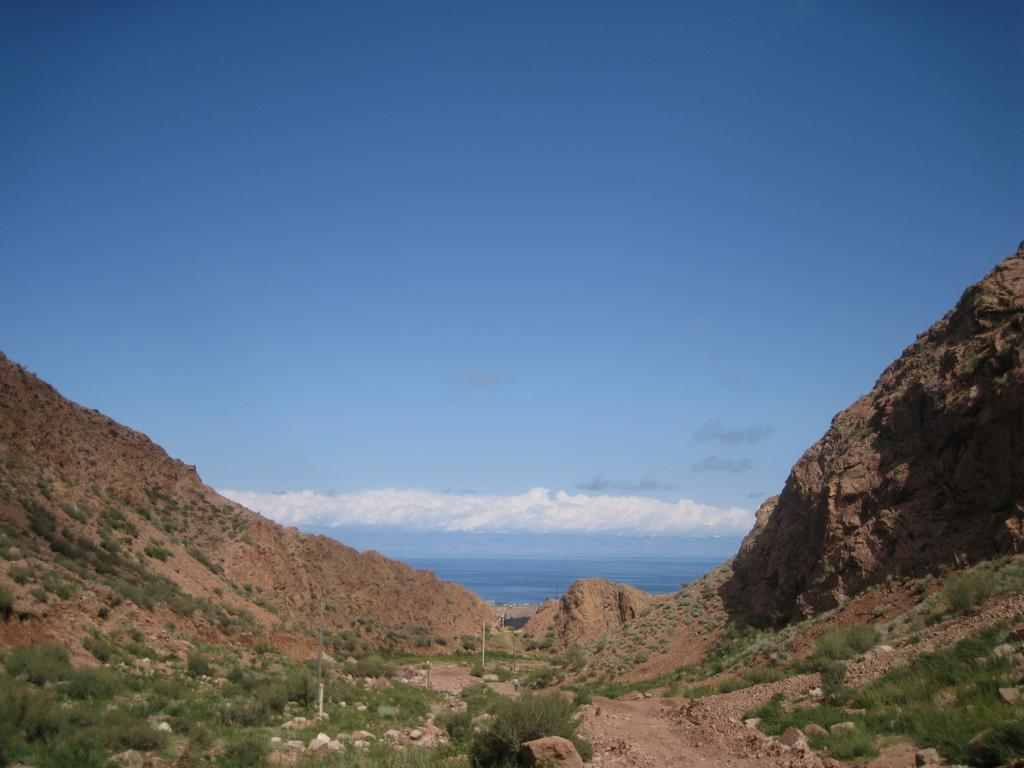What natural features are present on both sides of the image? There are mountains on both sides of the image. What can be found at the bottom of the image? There are stones and grass at the bottom of the image. What is visible in the background of the image? The sky, clouds, and water are visible in the background of the image. What type of development is taking place near the mountains in the image? There is no development or construction activity visible in the image; it primarily features natural elements. Can you tell me how many yams are growing near the grass in the image? There are no yams present in the image; it features grass and stones at the bottom. 